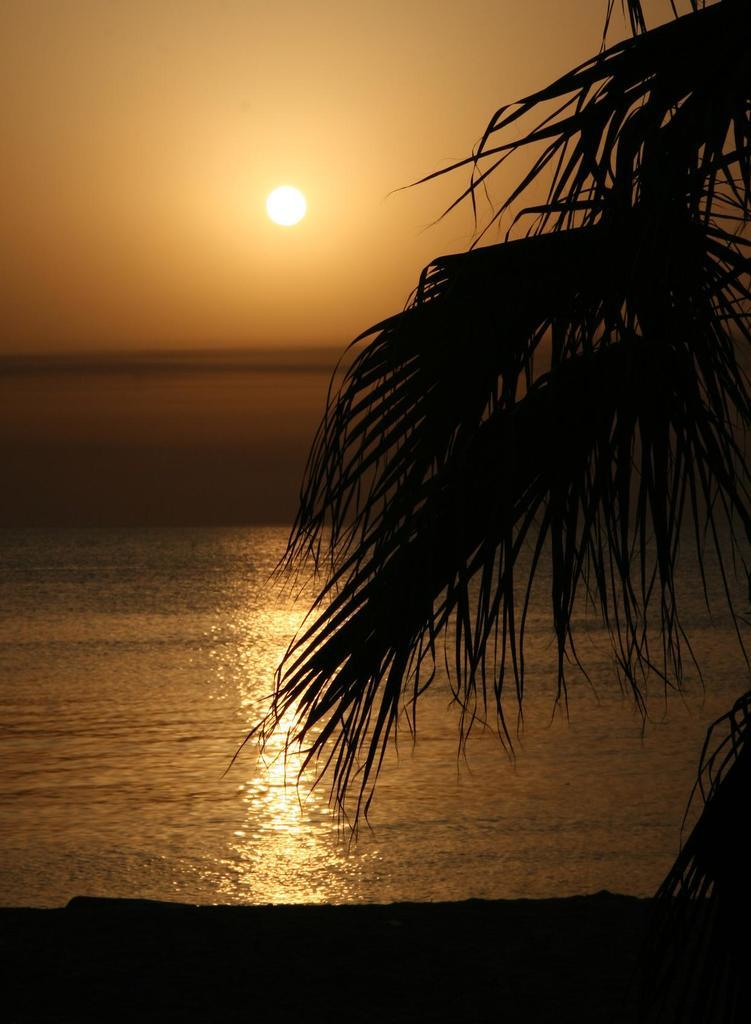What type of natural body of water is visible in the image? There is a sea in the image. What type of vegetation can be seen on the right side of the image? There is a tree on the right side of the image. What is visible at the top of the image? The sky is visible at the top of the image. What celestial body can be seen in the sky? The sun is present in the sky. What type of fabric is being rubbed on the tree in the image? There is no fabric or rubbing action present in the image. What type of mythical creature can be seen in the image? There is no mythical creature present in the image. 